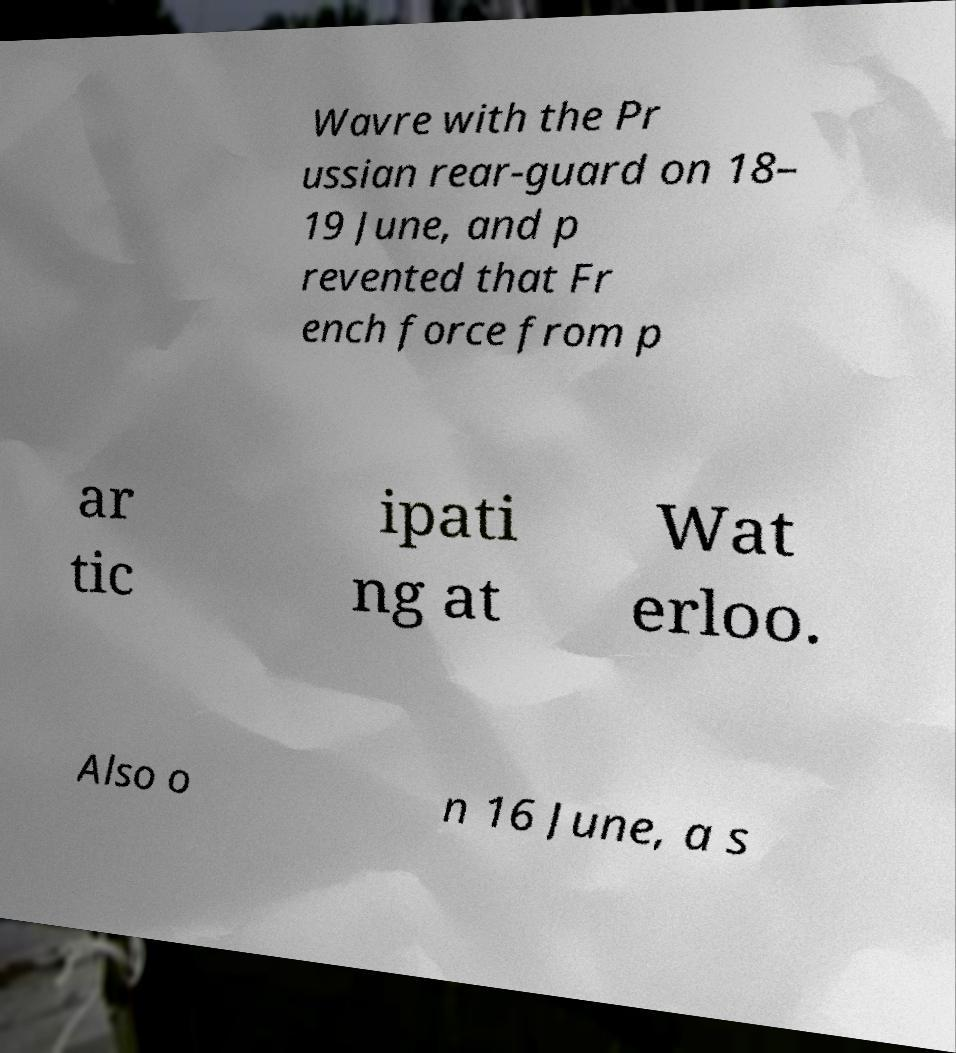What messages or text are displayed in this image? I need them in a readable, typed format. Wavre with the Pr ussian rear-guard on 18– 19 June, and p revented that Fr ench force from p ar tic ipati ng at Wat erloo. Also o n 16 June, a s 